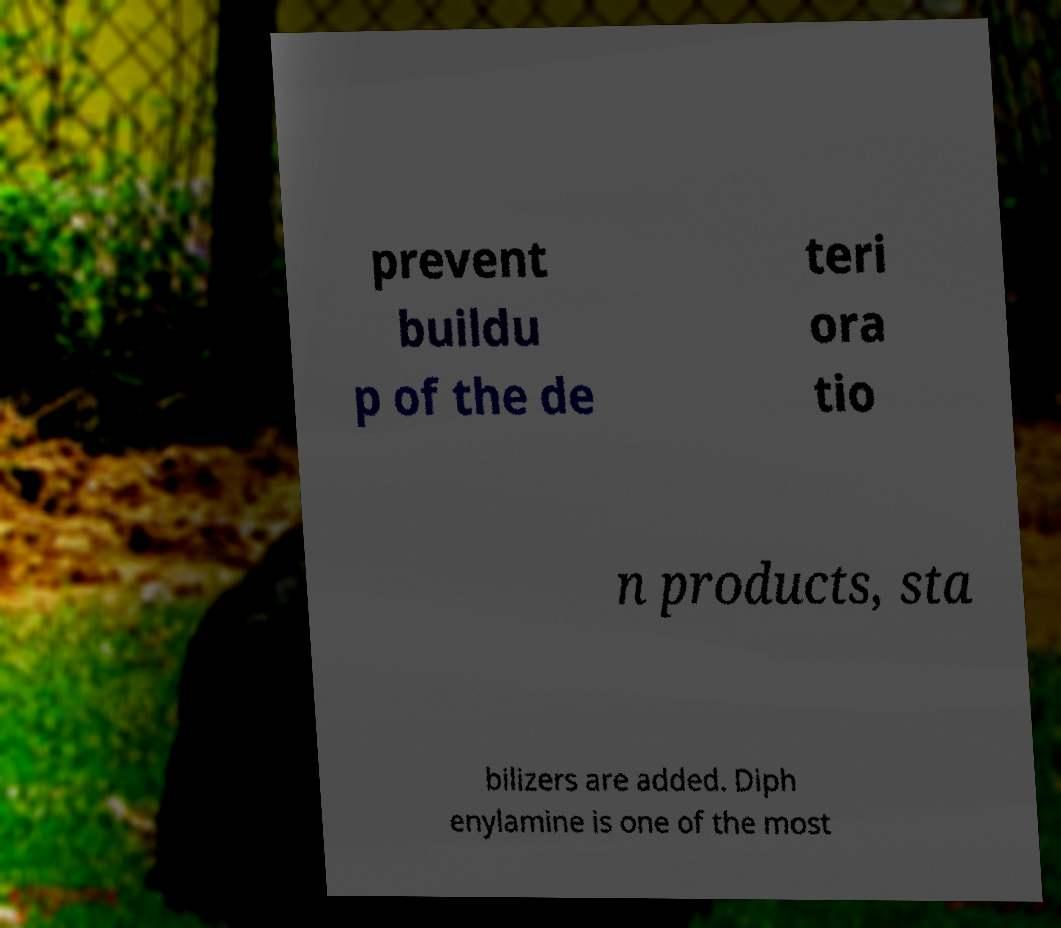For documentation purposes, I need the text within this image transcribed. Could you provide that? prevent buildu p of the de teri ora tio n products, sta bilizers are added. Diph enylamine is one of the most 